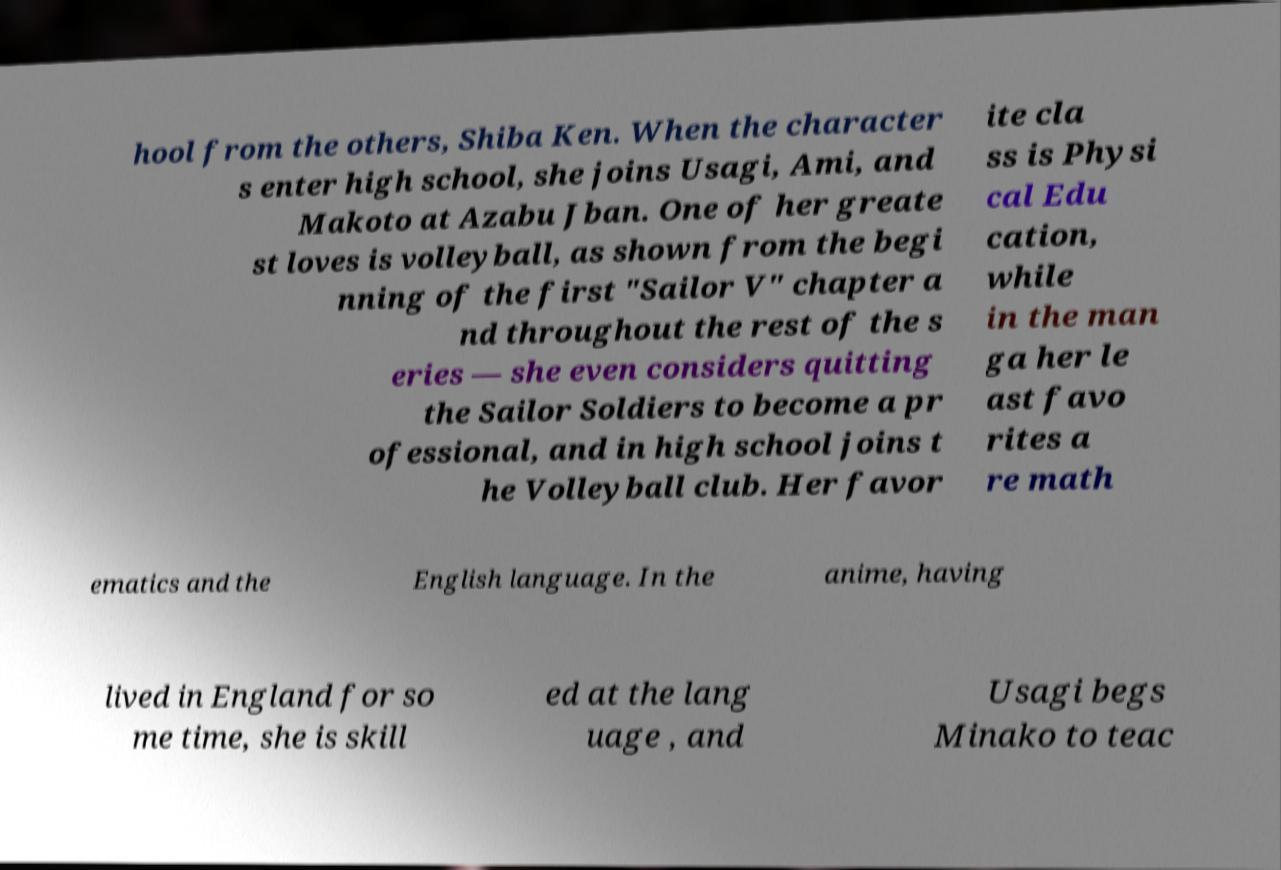Could you assist in decoding the text presented in this image and type it out clearly? hool from the others, Shiba Ken. When the character s enter high school, she joins Usagi, Ami, and Makoto at Azabu Jban. One of her greate st loves is volleyball, as shown from the begi nning of the first "Sailor V" chapter a nd throughout the rest of the s eries — she even considers quitting the Sailor Soldiers to become a pr ofessional, and in high school joins t he Volleyball club. Her favor ite cla ss is Physi cal Edu cation, while in the man ga her le ast favo rites a re math ematics and the English language. In the anime, having lived in England for so me time, she is skill ed at the lang uage , and Usagi begs Minako to teac 